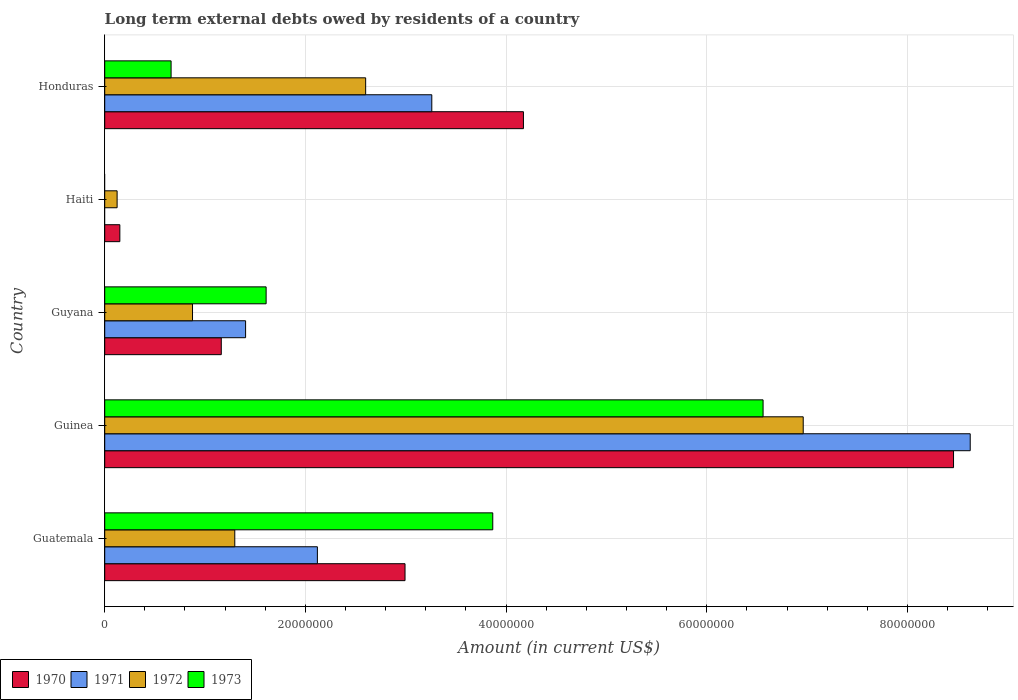Are the number of bars per tick equal to the number of legend labels?
Offer a terse response. No. How many bars are there on the 5th tick from the top?
Ensure brevity in your answer.  4. How many bars are there on the 2nd tick from the bottom?
Your answer should be very brief. 4. What is the label of the 1st group of bars from the top?
Make the answer very short. Honduras. What is the amount of long-term external debts owed by residents in 1973 in Guyana?
Make the answer very short. 1.61e+07. Across all countries, what is the maximum amount of long-term external debts owed by residents in 1972?
Provide a short and direct response. 6.96e+07. In which country was the amount of long-term external debts owed by residents in 1970 maximum?
Your answer should be very brief. Guinea. What is the total amount of long-term external debts owed by residents in 1973 in the graph?
Make the answer very short. 1.27e+08. What is the difference between the amount of long-term external debts owed by residents in 1971 in Guatemala and that in Guinea?
Your answer should be very brief. -6.51e+07. What is the difference between the amount of long-term external debts owed by residents in 1971 in Guatemala and the amount of long-term external debts owed by residents in 1972 in Haiti?
Your response must be concise. 2.00e+07. What is the average amount of long-term external debts owed by residents in 1972 per country?
Provide a short and direct response. 2.37e+07. What is the difference between the amount of long-term external debts owed by residents in 1973 and amount of long-term external debts owed by residents in 1972 in Honduras?
Ensure brevity in your answer.  -1.94e+07. What is the ratio of the amount of long-term external debts owed by residents in 1971 in Guatemala to that in Guyana?
Your response must be concise. 1.51. Is the amount of long-term external debts owed by residents in 1972 in Guinea less than that in Guyana?
Provide a short and direct response. No. Is the difference between the amount of long-term external debts owed by residents in 1973 in Guinea and Guyana greater than the difference between the amount of long-term external debts owed by residents in 1972 in Guinea and Guyana?
Your answer should be compact. No. What is the difference between the highest and the second highest amount of long-term external debts owed by residents in 1973?
Your answer should be very brief. 2.69e+07. What is the difference between the highest and the lowest amount of long-term external debts owed by residents in 1970?
Give a very brief answer. 8.31e+07. In how many countries, is the amount of long-term external debts owed by residents in 1972 greater than the average amount of long-term external debts owed by residents in 1972 taken over all countries?
Provide a short and direct response. 2. Is it the case that in every country, the sum of the amount of long-term external debts owed by residents in 1970 and amount of long-term external debts owed by residents in 1971 is greater than the amount of long-term external debts owed by residents in 1972?
Provide a short and direct response. Yes. Are all the bars in the graph horizontal?
Offer a very short reply. Yes. What is the difference between two consecutive major ticks on the X-axis?
Offer a terse response. 2.00e+07. How many legend labels are there?
Offer a terse response. 4. What is the title of the graph?
Your answer should be very brief. Long term external debts owed by residents of a country. Does "1968" appear as one of the legend labels in the graph?
Your response must be concise. No. What is the label or title of the X-axis?
Provide a succinct answer. Amount (in current US$). What is the Amount (in current US$) of 1970 in Guatemala?
Your response must be concise. 2.99e+07. What is the Amount (in current US$) of 1971 in Guatemala?
Your answer should be compact. 2.12e+07. What is the Amount (in current US$) of 1972 in Guatemala?
Provide a short and direct response. 1.30e+07. What is the Amount (in current US$) of 1973 in Guatemala?
Your answer should be compact. 3.87e+07. What is the Amount (in current US$) of 1970 in Guinea?
Your response must be concise. 8.46e+07. What is the Amount (in current US$) in 1971 in Guinea?
Give a very brief answer. 8.63e+07. What is the Amount (in current US$) in 1972 in Guinea?
Provide a short and direct response. 6.96e+07. What is the Amount (in current US$) in 1973 in Guinea?
Make the answer very short. 6.56e+07. What is the Amount (in current US$) of 1970 in Guyana?
Your answer should be compact. 1.16e+07. What is the Amount (in current US$) in 1971 in Guyana?
Offer a very short reply. 1.40e+07. What is the Amount (in current US$) of 1972 in Guyana?
Offer a very short reply. 8.75e+06. What is the Amount (in current US$) of 1973 in Guyana?
Your response must be concise. 1.61e+07. What is the Amount (in current US$) in 1970 in Haiti?
Provide a short and direct response. 1.51e+06. What is the Amount (in current US$) of 1971 in Haiti?
Your answer should be compact. 0. What is the Amount (in current US$) of 1972 in Haiti?
Keep it short and to the point. 1.24e+06. What is the Amount (in current US$) of 1970 in Honduras?
Ensure brevity in your answer.  4.17e+07. What is the Amount (in current US$) of 1971 in Honduras?
Your answer should be compact. 3.26e+07. What is the Amount (in current US$) in 1972 in Honduras?
Give a very brief answer. 2.60e+07. What is the Amount (in current US$) in 1973 in Honduras?
Offer a terse response. 6.62e+06. Across all countries, what is the maximum Amount (in current US$) of 1970?
Offer a terse response. 8.46e+07. Across all countries, what is the maximum Amount (in current US$) of 1971?
Your answer should be compact. 8.63e+07. Across all countries, what is the maximum Amount (in current US$) of 1972?
Your answer should be compact. 6.96e+07. Across all countries, what is the maximum Amount (in current US$) in 1973?
Your answer should be compact. 6.56e+07. Across all countries, what is the minimum Amount (in current US$) of 1970?
Ensure brevity in your answer.  1.51e+06. Across all countries, what is the minimum Amount (in current US$) of 1971?
Your answer should be compact. 0. Across all countries, what is the minimum Amount (in current US$) in 1972?
Provide a succinct answer. 1.24e+06. What is the total Amount (in current US$) in 1970 in the graph?
Offer a terse response. 1.69e+08. What is the total Amount (in current US$) in 1971 in the graph?
Offer a very short reply. 1.54e+08. What is the total Amount (in current US$) in 1972 in the graph?
Your response must be concise. 1.19e+08. What is the total Amount (in current US$) of 1973 in the graph?
Offer a terse response. 1.27e+08. What is the difference between the Amount (in current US$) of 1970 in Guatemala and that in Guinea?
Give a very brief answer. -5.47e+07. What is the difference between the Amount (in current US$) of 1971 in Guatemala and that in Guinea?
Keep it short and to the point. -6.51e+07. What is the difference between the Amount (in current US$) in 1972 in Guatemala and that in Guinea?
Keep it short and to the point. -5.67e+07. What is the difference between the Amount (in current US$) of 1973 in Guatemala and that in Guinea?
Your response must be concise. -2.69e+07. What is the difference between the Amount (in current US$) in 1970 in Guatemala and that in Guyana?
Provide a succinct answer. 1.83e+07. What is the difference between the Amount (in current US$) of 1971 in Guatemala and that in Guyana?
Offer a terse response. 7.16e+06. What is the difference between the Amount (in current US$) in 1972 in Guatemala and that in Guyana?
Offer a terse response. 4.21e+06. What is the difference between the Amount (in current US$) in 1973 in Guatemala and that in Guyana?
Provide a succinct answer. 2.26e+07. What is the difference between the Amount (in current US$) of 1970 in Guatemala and that in Haiti?
Your answer should be very brief. 2.84e+07. What is the difference between the Amount (in current US$) in 1972 in Guatemala and that in Haiti?
Make the answer very short. 1.17e+07. What is the difference between the Amount (in current US$) of 1970 in Guatemala and that in Honduras?
Your response must be concise. -1.18e+07. What is the difference between the Amount (in current US$) in 1971 in Guatemala and that in Honduras?
Make the answer very short. -1.14e+07. What is the difference between the Amount (in current US$) in 1972 in Guatemala and that in Honduras?
Offer a terse response. -1.30e+07. What is the difference between the Amount (in current US$) of 1973 in Guatemala and that in Honduras?
Make the answer very short. 3.21e+07. What is the difference between the Amount (in current US$) in 1970 in Guinea and that in Guyana?
Ensure brevity in your answer.  7.30e+07. What is the difference between the Amount (in current US$) of 1971 in Guinea and that in Guyana?
Ensure brevity in your answer.  7.22e+07. What is the difference between the Amount (in current US$) in 1972 in Guinea and that in Guyana?
Ensure brevity in your answer.  6.09e+07. What is the difference between the Amount (in current US$) of 1973 in Guinea and that in Guyana?
Give a very brief answer. 4.95e+07. What is the difference between the Amount (in current US$) of 1970 in Guinea and that in Haiti?
Give a very brief answer. 8.31e+07. What is the difference between the Amount (in current US$) of 1972 in Guinea and that in Haiti?
Keep it short and to the point. 6.84e+07. What is the difference between the Amount (in current US$) of 1970 in Guinea and that in Honduras?
Your answer should be very brief. 4.29e+07. What is the difference between the Amount (in current US$) in 1971 in Guinea and that in Honduras?
Provide a short and direct response. 5.37e+07. What is the difference between the Amount (in current US$) in 1972 in Guinea and that in Honduras?
Offer a very short reply. 4.36e+07. What is the difference between the Amount (in current US$) of 1973 in Guinea and that in Honduras?
Ensure brevity in your answer.  5.90e+07. What is the difference between the Amount (in current US$) of 1970 in Guyana and that in Haiti?
Your answer should be very brief. 1.01e+07. What is the difference between the Amount (in current US$) in 1972 in Guyana and that in Haiti?
Make the answer very short. 7.52e+06. What is the difference between the Amount (in current US$) in 1970 in Guyana and that in Honduras?
Your answer should be very brief. -3.01e+07. What is the difference between the Amount (in current US$) in 1971 in Guyana and that in Honduras?
Provide a succinct answer. -1.86e+07. What is the difference between the Amount (in current US$) in 1972 in Guyana and that in Honduras?
Give a very brief answer. -1.73e+07. What is the difference between the Amount (in current US$) of 1973 in Guyana and that in Honduras?
Keep it short and to the point. 9.47e+06. What is the difference between the Amount (in current US$) of 1970 in Haiti and that in Honduras?
Offer a very short reply. -4.02e+07. What is the difference between the Amount (in current US$) in 1972 in Haiti and that in Honduras?
Provide a short and direct response. -2.48e+07. What is the difference between the Amount (in current US$) in 1970 in Guatemala and the Amount (in current US$) in 1971 in Guinea?
Your answer should be very brief. -5.63e+07. What is the difference between the Amount (in current US$) of 1970 in Guatemala and the Amount (in current US$) of 1972 in Guinea?
Your answer should be compact. -3.97e+07. What is the difference between the Amount (in current US$) in 1970 in Guatemala and the Amount (in current US$) in 1973 in Guinea?
Make the answer very short. -3.57e+07. What is the difference between the Amount (in current US$) in 1971 in Guatemala and the Amount (in current US$) in 1972 in Guinea?
Your response must be concise. -4.84e+07. What is the difference between the Amount (in current US$) in 1971 in Guatemala and the Amount (in current US$) in 1973 in Guinea?
Offer a terse response. -4.44e+07. What is the difference between the Amount (in current US$) in 1972 in Guatemala and the Amount (in current US$) in 1973 in Guinea?
Your answer should be compact. -5.27e+07. What is the difference between the Amount (in current US$) in 1970 in Guatemala and the Amount (in current US$) in 1971 in Guyana?
Offer a very short reply. 1.59e+07. What is the difference between the Amount (in current US$) in 1970 in Guatemala and the Amount (in current US$) in 1972 in Guyana?
Your response must be concise. 2.12e+07. What is the difference between the Amount (in current US$) of 1970 in Guatemala and the Amount (in current US$) of 1973 in Guyana?
Give a very brief answer. 1.38e+07. What is the difference between the Amount (in current US$) of 1971 in Guatemala and the Amount (in current US$) of 1972 in Guyana?
Provide a short and direct response. 1.24e+07. What is the difference between the Amount (in current US$) of 1971 in Guatemala and the Amount (in current US$) of 1973 in Guyana?
Keep it short and to the point. 5.11e+06. What is the difference between the Amount (in current US$) in 1972 in Guatemala and the Amount (in current US$) in 1973 in Guyana?
Your response must be concise. -3.12e+06. What is the difference between the Amount (in current US$) of 1970 in Guatemala and the Amount (in current US$) of 1972 in Haiti?
Provide a succinct answer. 2.87e+07. What is the difference between the Amount (in current US$) of 1971 in Guatemala and the Amount (in current US$) of 1972 in Haiti?
Ensure brevity in your answer.  2.00e+07. What is the difference between the Amount (in current US$) of 1970 in Guatemala and the Amount (in current US$) of 1971 in Honduras?
Offer a terse response. -2.67e+06. What is the difference between the Amount (in current US$) in 1970 in Guatemala and the Amount (in current US$) in 1972 in Honduras?
Give a very brief answer. 3.92e+06. What is the difference between the Amount (in current US$) in 1970 in Guatemala and the Amount (in current US$) in 1973 in Honduras?
Provide a succinct answer. 2.33e+07. What is the difference between the Amount (in current US$) of 1971 in Guatemala and the Amount (in current US$) of 1972 in Honduras?
Make the answer very short. -4.81e+06. What is the difference between the Amount (in current US$) in 1971 in Guatemala and the Amount (in current US$) in 1973 in Honduras?
Keep it short and to the point. 1.46e+07. What is the difference between the Amount (in current US$) in 1972 in Guatemala and the Amount (in current US$) in 1973 in Honduras?
Your answer should be very brief. 6.35e+06. What is the difference between the Amount (in current US$) in 1970 in Guinea and the Amount (in current US$) in 1971 in Guyana?
Your response must be concise. 7.06e+07. What is the difference between the Amount (in current US$) of 1970 in Guinea and the Amount (in current US$) of 1972 in Guyana?
Your response must be concise. 7.58e+07. What is the difference between the Amount (in current US$) in 1970 in Guinea and the Amount (in current US$) in 1973 in Guyana?
Provide a succinct answer. 6.85e+07. What is the difference between the Amount (in current US$) of 1971 in Guinea and the Amount (in current US$) of 1972 in Guyana?
Your answer should be compact. 7.75e+07. What is the difference between the Amount (in current US$) in 1971 in Guinea and the Amount (in current US$) in 1973 in Guyana?
Give a very brief answer. 7.02e+07. What is the difference between the Amount (in current US$) in 1972 in Guinea and the Amount (in current US$) in 1973 in Guyana?
Your response must be concise. 5.35e+07. What is the difference between the Amount (in current US$) of 1970 in Guinea and the Amount (in current US$) of 1972 in Haiti?
Give a very brief answer. 8.34e+07. What is the difference between the Amount (in current US$) in 1971 in Guinea and the Amount (in current US$) in 1972 in Haiti?
Give a very brief answer. 8.50e+07. What is the difference between the Amount (in current US$) of 1970 in Guinea and the Amount (in current US$) of 1971 in Honduras?
Provide a succinct answer. 5.20e+07. What is the difference between the Amount (in current US$) in 1970 in Guinea and the Amount (in current US$) in 1972 in Honduras?
Ensure brevity in your answer.  5.86e+07. What is the difference between the Amount (in current US$) of 1970 in Guinea and the Amount (in current US$) of 1973 in Honduras?
Your answer should be compact. 7.80e+07. What is the difference between the Amount (in current US$) in 1971 in Guinea and the Amount (in current US$) in 1972 in Honduras?
Provide a short and direct response. 6.03e+07. What is the difference between the Amount (in current US$) of 1971 in Guinea and the Amount (in current US$) of 1973 in Honduras?
Give a very brief answer. 7.96e+07. What is the difference between the Amount (in current US$) of 1972 in Guinea and the Amount (in current US$) of 1973 in Honduras?
Keep it short and to the point. 6.30e+07. What is the difference between the Amount (in current US$) in 1970 in Guyana and the Amount (in current US$) in 1972 in Haiti?
Ensure brevity in your answer.  1.04e+07. What is the difference between the Amount (in current US$) in 1971 in Guyana and the Amount (in current US$) in 1972 in Haiti?
Offer a terse response. 1.28e+07. What is the difference between the Amount (in current US$) of 1970 in Guyana and the Amount (in current US$) of 1971 in Honduras?
Provide a short and direct response. -2.10e+07. What is the difference between the Amount (in current US$) of 1970 in Guyana and the Amount (in current US$) of 1972 in Honduras?
Keep it short and to the point. -1.44e+07. What is the difference between the Amount (in current US$) in 1970 in Guyana and the Amount (in current US$) in 1973 in Honduras?
Provide a short and direct response. 5.00e+06. What is the difference between the Amount (in current US$) of 1971 in Guyana and the Amount (in current US$) of 1972 in Honduras?
Your response must be concise. -1.20e+07. What is the difference between the Amount (in current US$) in 1971 in Guyana and the Amount (in current US$) in 1973 in Honduras?
Keep it short and to the point. 7.42e+06. What is the difference between the Amount (in current US$) of 1972 in Guyana and the Amount (in current US$) of 1973 in Honduras?
Your answer should be compact. 2.14e+06. What is the difference between the Amount (in current US$) in 1970 in Haiti and the Amount (in current US$) in 1971 in Honduras?
Your answer should be compact. -3.11e+07. What is the difference between the Amount (in current US$) in 1970 in Haiti and the Amount (in current US$) in 1972 in Honduras?
Make the answer very short. -2.45e+07. What is the difference between the Amount (in current US$) in 1970 in Haiti and the Amount (in current US$) in 1973 in Honduras?
Make the answer very short. -5.11e+06. What is the difference between the Amount (in current US$) of 1972 in Haiti and the Amount (in current US$) of 1973 in Honduras?
Make the answer very short. -5.38e+06. What is the average Amount (in current US$) of 1970 per country?
Give a very brief answer. 3.39e+07. What is the average Amount (in current US$) in 1971 per country?
Provide a short and direct response. 3.08e+07. What is the average Amount (in current US$) in 1972 per country?
Your answer should be very brief. 2.37e+07. What is the average Amount (in current US$) in 1973 per country?
Offer a very short reply. 2.54e+07. What is the difference between the Amount (in current US$) in 1970 and Amount (in current US$) in 1971 in Guatemala?
Give a very brief answer. 8.73e+06. What is the difference between the Amount (in current US$) in 1970 and Amount (in current US$) in 1972 in Guatemala?
Your answer should be compact. 1.70e+07. What is the difference between the Amount (in current US$) of 1970 and Amount (in current US$) of 1973 in Guatemala?
Your answer should be very brief. -8.74e+06. What is the difference between the Amount (in current US$) of 1971 and Amount (in current US$) of 1972 in Guatemala?
Make the answer very short. 8.23e+06. What is the difference between the Amount (in current US$) of 1971 and Amount (in current US$) of 1973 in Guatemala?
Provide a succinct answer. -1.75e+07. What is the difference between the Amount (in current US$) of 1972 and Amount (in current US$) of 1973 in Guatemala?
Your answer should be very brief. -2.57e+07. What is the difference between the Amount (in current US$) in 1970 and Amount (in current US$) in 1971 in Guinea?
Keep it short and to the point. -1.66e+06. What is the difference between the Amount (in current US$) in 1970 and Amount (in current US$) in 1972 in Guinea?
Offer a terse response. 1.50e+07. What is the difference between the Amount (in current US$) in 1970 and Amount (in current US$) in 1973 in Guinea?
Give a very brief answer. 1.90e+07. What is the difference between the Amount (in current US$) of 1971 and Amount (in current US$) of 1972 in Guinea?
Ensure brevity in your answer.  1.66e+07. What is the difference between the Amount (in current US$) in 1971 and Amount (in current US$) in 1973 in Guinea?
Make the answer very short. 2.06e+07. What is the difference between the Amount (in current US$) of 1972 and Amount (in current US$) of 1973 in Guinea?
Offer a terse response. 4.00e+06. What is the difference between the Amount (in current US$) in 1970 and Amount (in current US$) in 1971 in Guyana?
Give a very brief answer. -2.42e+06. What is the difference between the Amount (in current US$) of 1970 and Amount (in current US$) of 1972 in Guyana?
Keep it short and to the point. 2.87e+06. What is the difference between the Amount (in current US$) in 1970 and Amount (in current US$) in 1973 in Guyana?
Keep it short and to the point. -4.47e+06. What is the difference between the Amount (in current US$) of 1971 and Amount (in current US$) of 1972 in Guyana?
Offer a very short reply. 5.29e+06. What is the difference between the Amount (in current US$) of 1971 and Amount (in current US$) of 1973 in Guyana?
Ensure brevity in your answer.  -2.05e+06. What is the difference between the Amount (in current US$) in 1972 and Amount (in current US$) in 1973 in Guyana?
Keep it short and to the point. -7.34e+06. What is the difference between the Amount (in current US$) of 1970 and Amount (in current US$) of 1972 in Haiti?
Keep it short and to the point. 2.72e+05. What is the difference between the Amount (in current US$) in 1970 and Amount (in current US$) in 1971 in Honduras?
Your answer should be very brief. 9.13e+06. What is the difference between the Amount (in current US$) of 1970 and Amount (in current US$) of 1972 in Honduras?
Your response must be concise. 1.57e+07. What is the difference between the Amount (in current US$) in 1970 and Amount (in current US$) in 1973 in Honduras?
Offer a very short reply. 3.51e+07. What is the difference between the Amount (in current US$) of 1971 and Amount (in current US$) of 1972 in Honduras?
Offer a terse response. 6.59e+06. What is the difference between the Amount (in current US$) of 1971 and Amount (in current US$) of 1973 in Honduras?
Make the answer very short. 2.60e+07. What is the difference between the Amount (in current US$) in 1972 and Amount (in current US$) in 1973 in Honduras?
Make the answer very short. 1.94e+07. What is the ratio of the Amount (in current US$) of 1970 in Guatemala to that in Guinea?
Your answer should be compact. 0.35. What is the ratio of the Amount (in current US$) of 1971 in Guatemala to that in Guinea?
Your answer should be compact. 0.25. What is the ratio of the Amount (in current US$) in 1972 in Guatemala to that in Guinea?
Offer a terse response. 0.19. What is the ratio of the Amount (in current US$) of 1973 in Guatemala to that in Guinea?
Make the answer very short. 0.59. What is the ratio of the Amount (in current US$) of 1970 in Guatemala to that in Guyana?
Provide a short and direct response. 2.58. What is the ratio of the Amount (in current US$) of 1971 in Guatemala to that in Guyana?
Your answer should be compact. 1.51. What is the ratio of the Amount (in current US$) of 1972 in Guatemala to that in Guyana?
Provide a short and direct response. 1.48. What is the ratio of the Amount (in current US$) of 1973 in Guatemala to that in Guyana?
Your answer should be very brief. 2.4. What is the ratio of the Amount (in current US$) in 1970 in Guatemala to that in Haiti?
Your response must be concise. 19.86. What is the ratio of the Amount (in current US$) in 1972 in Guatemala to that in Haiti?
Offer a very short reply. 10.5. What is the ratio of the Amount (in current US$) in 1970 in Guatemala to that in Honduras?
Offer a very short reply. 0.72. What is the ratio of the Amount (in current US$) in 1971 in Guatemala to that in Honduras?
Offer a terse response. 0.65. What is the ratio of the Amount (in current US$) in 1972 in Guatemala to that in Honduras?
Provide a short and direct response. 0.5. What is the ratio of the Amount (in current US$) of 1973 in Guatemala to that in Honduras?
Your answer should be very brief. 5.85. What is the ratio of the Amount (in current US$) of 1970 in Guinea to that in Guyana?
Provide a succinct answer. 7.28. What is the ratio of the Amount (in current US$) of 1971 in Guinea to that in Guyana?
Offer a terse response. 6.14. What is the ratio of the Amount (in current US$) of 1972 in Guinea to that in Guyana?
Provide a succinct answer. 7.96. What is the ratio of the Amount (in current US$) of 1973 in Guinea to that in Guyana?
Give a very brief answer. 4.08. What is the ratio of the Amount (in current US$) in 1970 in Guinea to that in Haiti?
Your response must be concise. 56.14. What is the ratio of the Amount (in current US$) of 1972 in Guinea to that in Haiti?
Provide a short and direct response. 56.37. What is the ratio of the Amount (in current US$) in 1970 in Guinea to that in Honduras?
Your answer should be compact. 2.03. What is the ratio of the Amount (in current US$) in 1971 in Guinea to that in Honduras?
Offer a very short reply. 2.65. What is the ratio of the Amount (in current US$) of 1972 in Guinea to that in Honduras?
Keep it short and to the point. 2.68. What is the ratio of the Amount (in current US$) in 1973 in Guinea to that in Honduras?
Your response must be concise. 9.92. What is the ratio of the Amount (in current US$) in 1970 in Guyana to that in Haiti?
Offer a terse response. 7.71. What is the ratio of the Amount (in current US$) in 1972 in Guyana to that in Haiti?
Give a very brief answer. 7.09. What is the ratio of the Amount (in current US$) of 1970 in Guyana to that in Honduras?
Keep it short and to the point. 0.28. What is the ratio of the Amount (in current US$) in 1971 in Guyana to that in Honduras?
Your answer should be compact. 0.43. What is the ratio of the Amount (in current US$) of 1972 in Guyana to that in Honduras?
Your response must be concise. 0.34. What is the ratio of the Amount (in current US$) of 1973 in Guyana to that in Honduras?
Offer a terse response. 2.43. What is the ratio of the Amount (in current US$) of 1970 in Haiti to that in Honduras?
Provide a short and direct response. 0.04. What is the ratio of the Amount (in current US$) in 1972 in Haiti to that in Honduras?
Provide a short and direct response. 0.05. What is the difference between the highest and the second highest Amount (in current US$) of 1970?
Provide a succinct answer. 4.29e+07. What is the difference between the highest and the second highest Amount (in current US$) in 1971?
Offer a very short reply. 5.37e+07. What is the difference between the highest and the second highest Amount (in current US$) of 1972?
Give a very brief answer. 4.36e+07. What is the difference between the highest and the second highest Amount (in current US$) of 1973?
Keep it short and to the point. 2.69e+07. What is the difference between the highest and the lowest Amount (in current US$) of 1970?
Make the answer very short. 8.31e+07. What is the difference between the highest and the lowest Amount (in current US$) of 1971?
Your answer should be compact. 8.63e+07. What is the difference between the highest and the lowest Amount (in current US$) in 1972?
Make the answer very short. 6.84e+07. What is the difference between the highest and the lowest Amount (in current US$) of 1973?
Your answer should be very brief. 6.56e+07. 